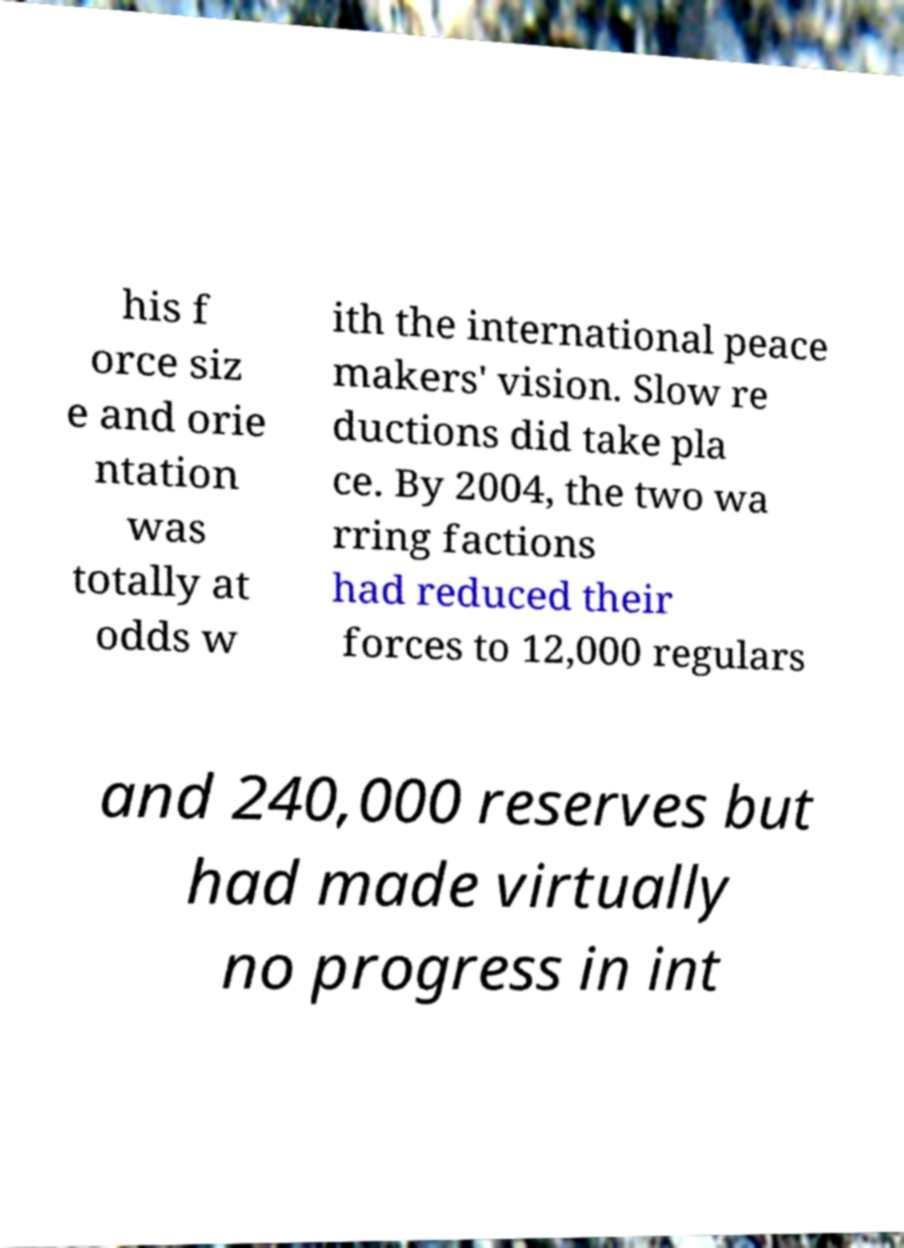Could you assist in decoding the text presented in this image and type it out clearly? his f orce siz e and orie ntation was totally at odds w ith the international peace makers' vision. Slow re ductions did take pla ce. By 2004, the two wa rring factions had reduced their forces to 12,000 regulars and 240,000 reserves but had made virtually no progress in int 